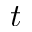<formula> <loc_0><loc_0><loc_500><loc_500>t</formula> 